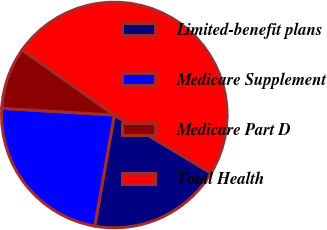Convert chart to OTSL. <chart><loc_0><loc_0><loc_500><loc_500><pie_chart><fcel>Limited-benefit plans<fcel>Medicare Supplement<fcel>Medicare Part D<fcel>Total Health<nl><fcel>19.18%<fcel>23.17%<fcel>8.84%<fcel>48.81%<nl></chart> 